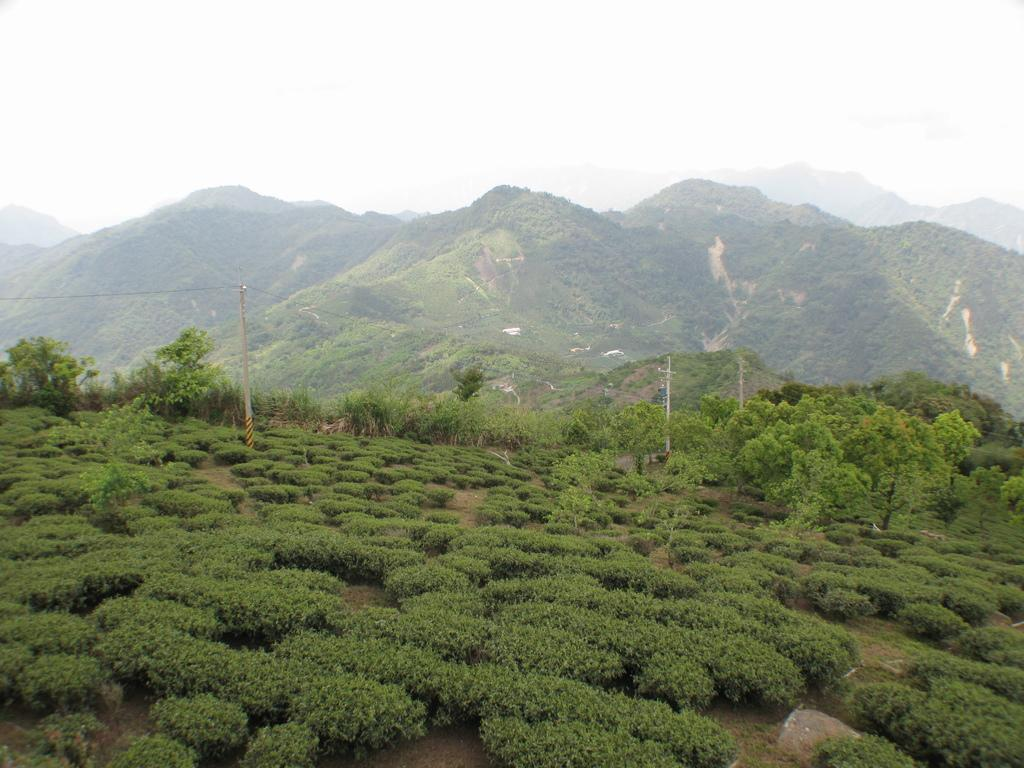What is the main subject of the image? The main subject of the image is a tea plantation. What can be seen in the background of the image? In the background, there are electric poles with wires, trees, hills, and the sky. Can you describe the landscape surrounding the tea plantation? The landscape includes trees, hills, and electric poles with wires in the background. What is visible in the sky in the image? The sky is visible in the background of the image. What type of cast can be seen on the son's arm in the image? There is no cast or son present in the image; it features a tea plantation and background elements. 